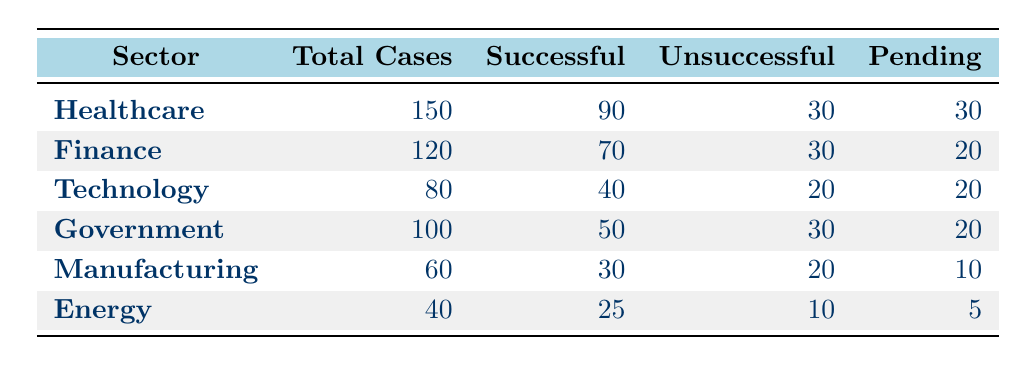What sector had the highest number of total cases? By looking at the "Total Cases" column, we see that "Healthcare" has the highest value at 150 cases compared to other sectors listed.
Answer: Healthcare What was the number of successful resolutions in the Finance sector? The "Successful" column in the "Finance" row shows a value of 70, indicating the number of successful resolutions for cases within that sector.
Answer: 70 How many total cases were there in the Energy sector? Referring to the "Total Cases" column, the "Energy" row has a total of 40 cases, indicating the overall number of whistleblower cases in that sector.
Answer: 40 What is the total number of unsuccessful resolutions across all sectors? To find this, we add the "Unsuccessful" values from each sector: 30 (Healthcare) + 30 (Finance) + 20 (Technology) + 30 (Government) + 20 (Manufacturing) + 10 (Energy) = 150.
Answer: 150 Is it true that the Technology sector had more successful resolutions than the Manufacturing sector? By comparing the "Successful" values, Technology has 40 successful resolutions while Manufacturing has 30, confirming that Technology indeed had more successful resolutions.
Answer: Yes What is the percentage of successful resolutions in the Healthcare sector? The percentage is calculated by dividing the successful resolutions (90) by the total cases (150) and then multiplying by 100: (90/150) * 100 = 60%.
Answer: 60% Which sector had the lowest number of pending cases? Reviewing the "Pending" column, "Energy" has the lowest value at 5 pending cases when compared to other sectors.
Answer: Energy What is the average number of pending cases across all sectors? To find the average, we sum the pending cases: 30 (Healthcare) + 20 (Finance) + 20 (Technology) + 20 (Government) + 10 (Manufacturing) + 5 (Energy) = 105. Then, divide by the number of sectors (6): 105/6 = 17.5.
Answer: 17.5 Are there more total cases in the Government sector than in the Manufacturing sector? Comparing the "Total Cases" values, Government has 100 total cases, while Manufacturing has 60 cases, confirming that Government has more cases.
Answer: Yes 